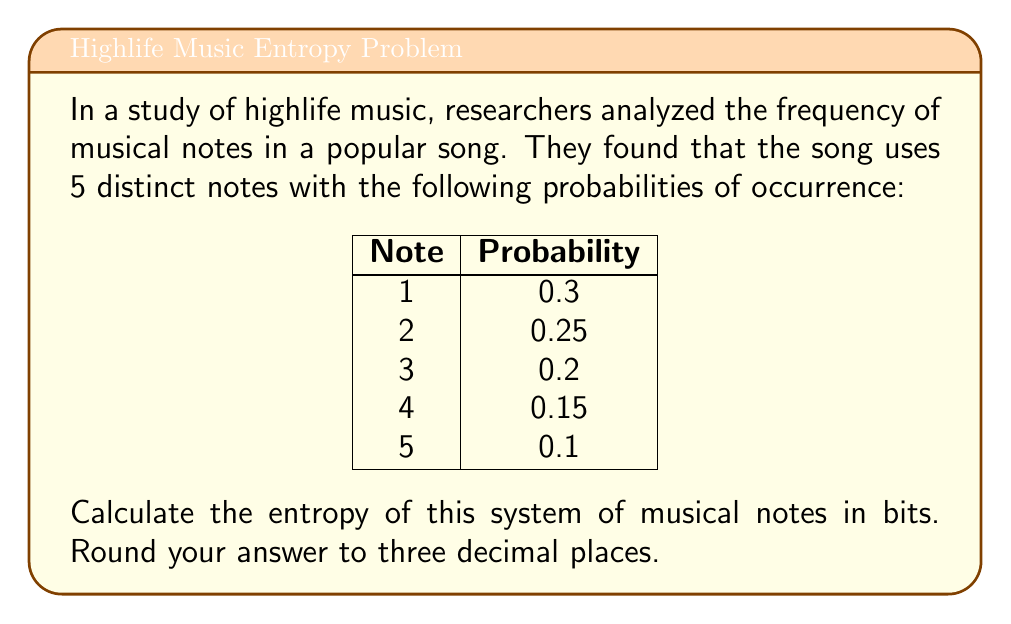Solve this math problem. To calculate the entropy of this system, we'll use the Shannon entropy formula:

$$ S = -\sum_{i=1}^{n} p_i \log_2(p_i) $$

Where $S$ is the entropy, $p_i$ is the probability of each state (note in this case), and $n$ is the number of states.

Let's calculate for each note:

1. Note 1: $-0.3 \log_2(0.3) = 0.521$
2. Note 2: $-0.25 \log_2(0.25) = 0.5$
3. Note 3: $-0.2 \log_2(0.2) = 0.464$
4. Note 4: $-0.15 \log_2(0.15) = 0.411$
5. Note 5: $-0.1 \log_2(0.1) = 0.332$

Now, sum these values:

$$ S = 0.521 + 0.5 + 0.464 + 0.411 + 0.332 = 2.228 $$

Rounding to three decimal places, we get 2.228 bits.
Answer: 2.228 bits 